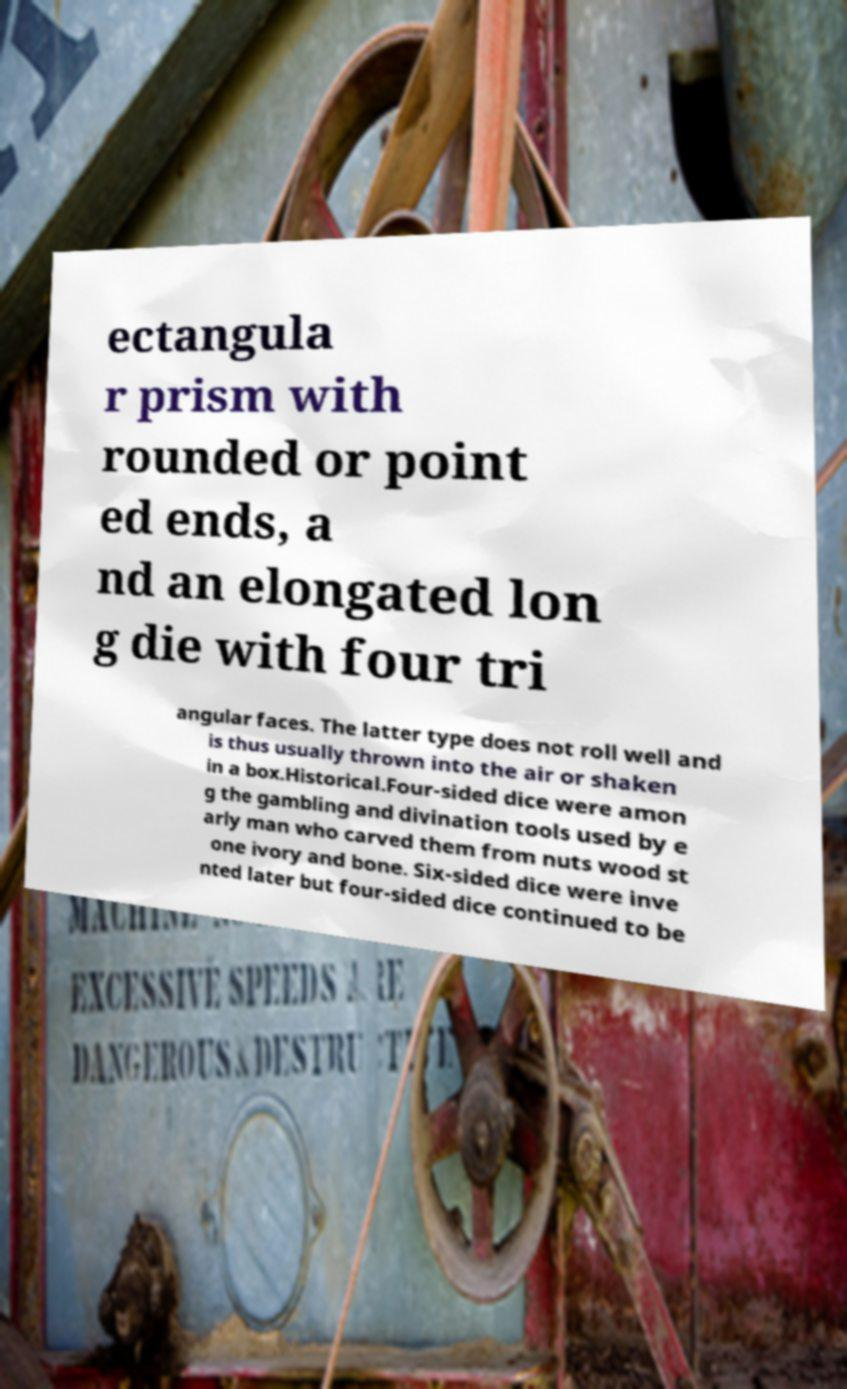Please read and relay the text visible in this image. What does it say? ectangula r prism with rounded or point ed ends, a nd an elongated lon g die with four tri angular faces. The latter type does not roll well and is thus usually thrown into the air or shaken in a box.Historical.Four-sided dice were amon g the gambling and divination tools used by e arly man who carved them from nuts wood st one ivory and bone. Six-sided dice were inve nted later but four-sided dice continued to be 